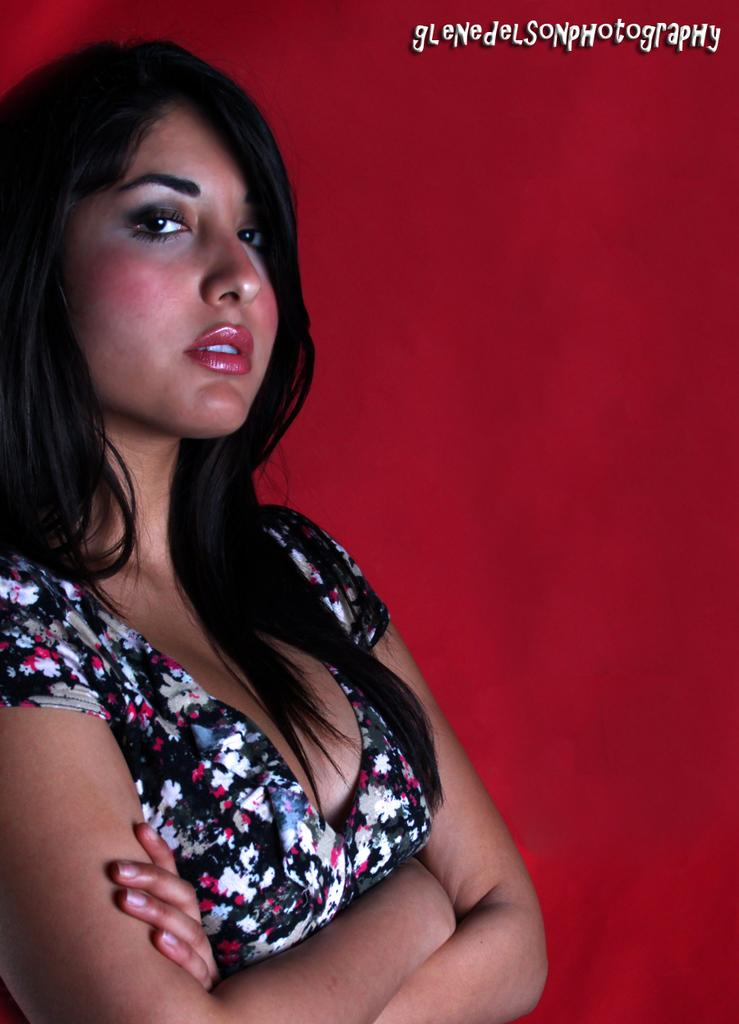What is the main subject of the image? There is a woman standing in the image. What color is the background of the image? The background of the image is red. Can you describe any additional features of the image? There is a watermark on the image. What type of fruit can be seen crawling on the woman's shoulder in the image? There is no fruit or any crawling object visible on the woman's shoulder in the image. 